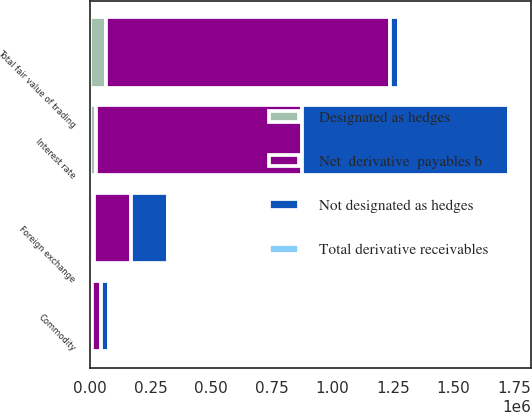Convert chart to OTSL. <chart><loc_0><loc_0><loc_500><loc_500><stacked_bar_chart><ecel><fcel>Interest rate<fcel>Foreign exchange<fcel>Commodity<fcel>Total fair value of trading<nl><fcel>Net  derivative  payables b<fcel>851189<fcel>152240<fcel>34344<fcel>1.17422e+06<nl><fcel>Total derivative receivables<fcel>3490<fcel>1359<fcel>1394<fcel>6243<nl><fcel>Not designated as hedges<fcel>854679<fcel>153599<fcel>35738<fcel>34344<nl><fcel>Designated as hedges<fcel>25782<fcel>16790<fcel>9444<fcel>65759<nl></chart> 